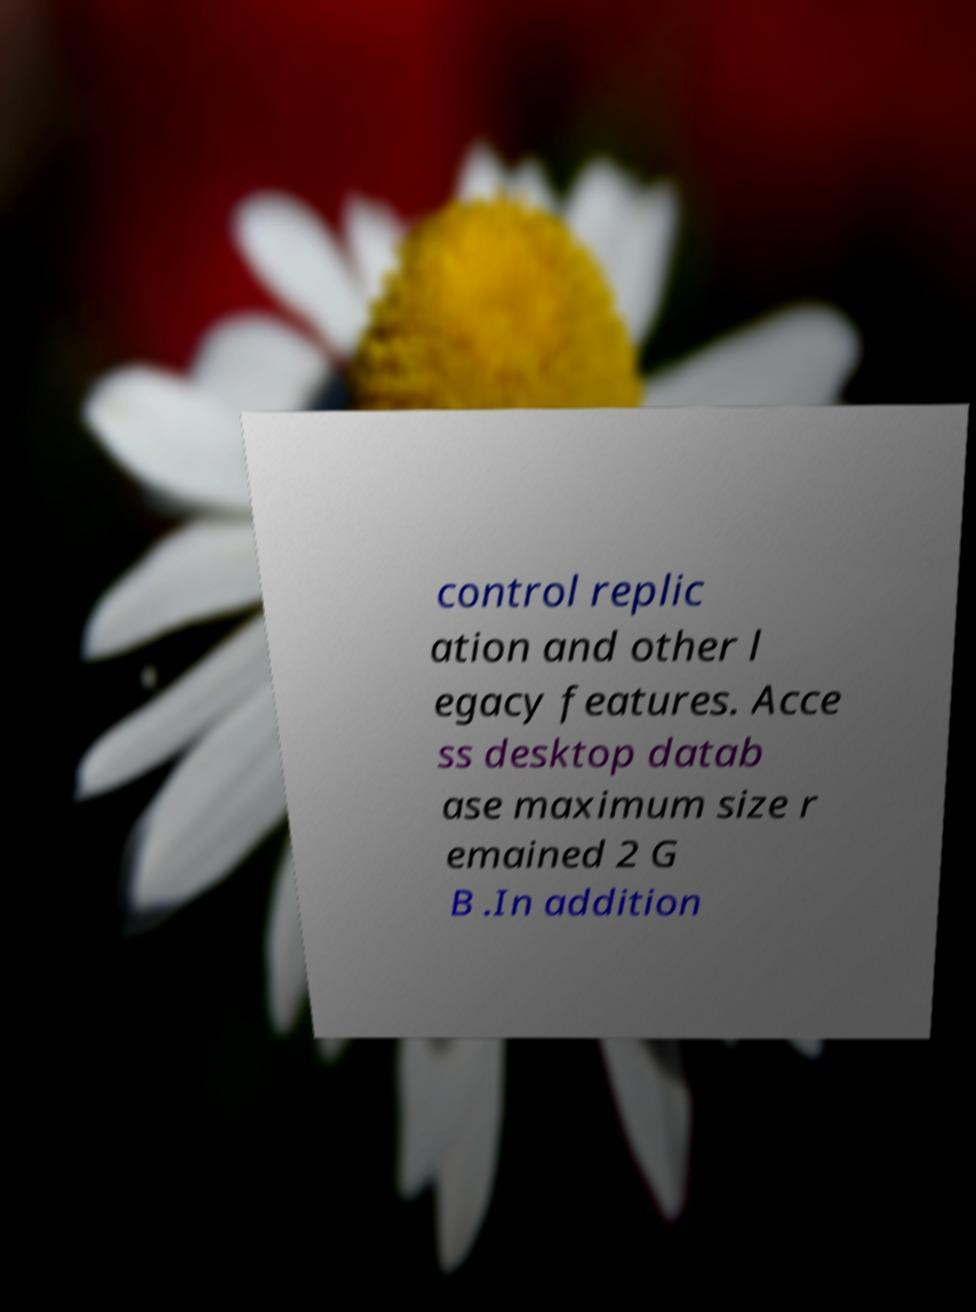Can you accurately transcribe the text from the provided image for me? control replic ation and other l egacy features. Acce ss desktop datab ase maximum size r emained 2 G B .In addition 